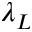Convert formula to latex. <formula><loc_0><loc_0><loc_500><loc_500>\lambda _ { L }</formula> 